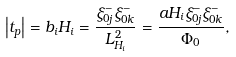Convert formula to latex. <formula><loc_0><loc_0><loc_500><loc_500>\left | t _ { p } \right | = b _ { i } H _ { i } = \frac { \xi _ { 0 j } ^ { - } \xi _ { 0 k } ^ { - } } { L _ { H _ { i } } ^ { 2 } } = \frac { a H _ { i } \xi _ { 0 j } ^ { - } \xi _ { 0 k } ^ { - } } { \Phi _ { 0 } } ,</formula> 